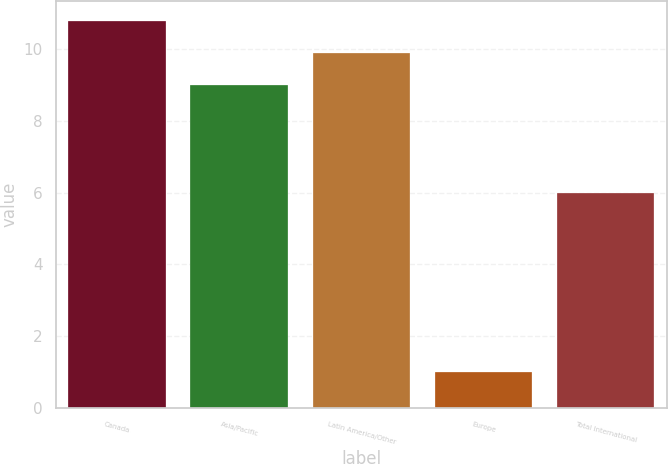<chart> <loc_0><loc_0><loc_500><loc_500><bar_chart><fcel>Canada<fcel>Asia/Pacific<fcel>Latin America/Other<fcel>Europe<fcel>Total International<nl><fcel>10.8<fcel>9<fcel>9.9<fcel>1<fcel>6<nl></chart> 